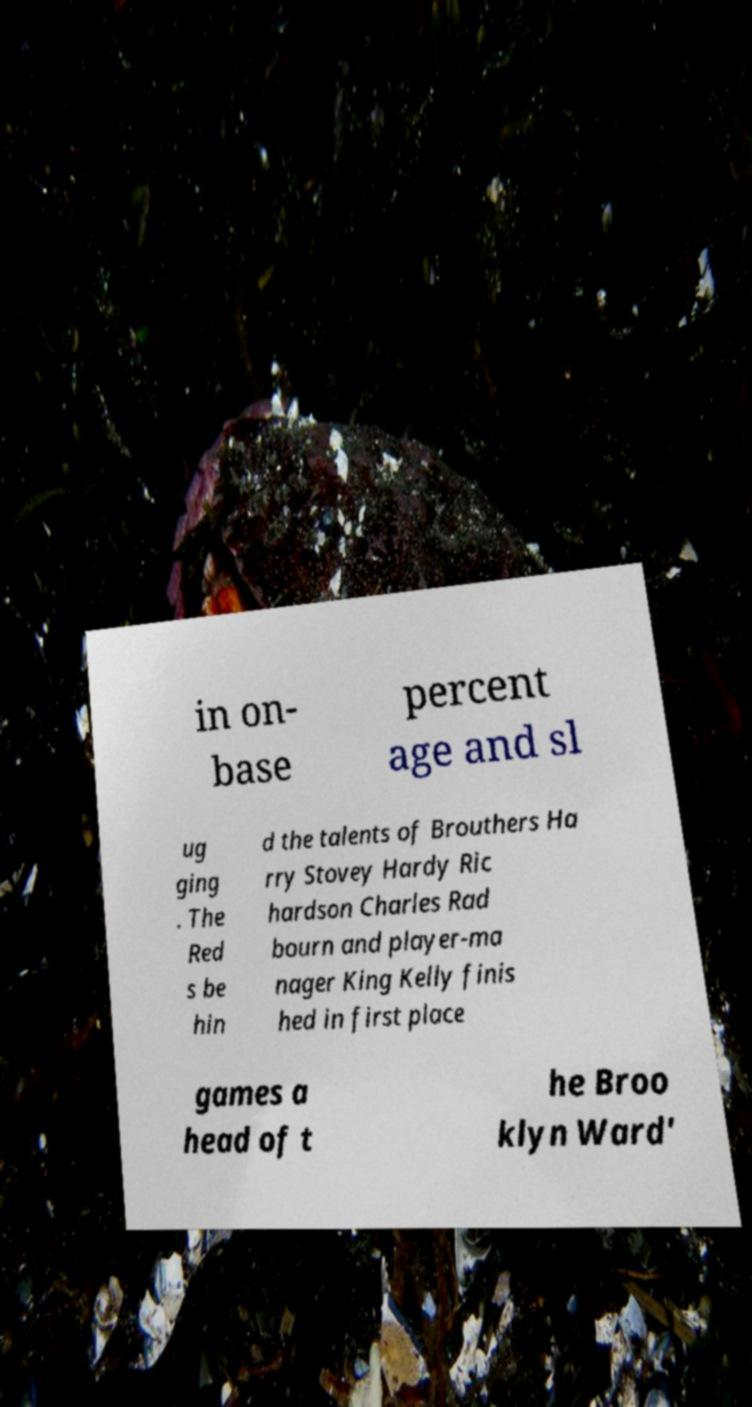I need the written content from this picture converted into text. Can you do that? in on- base percent age and sl ug ging . The Red s be hin d the talents of Brouthers Ha rry Stovey Hardy Ric hardson Charles Rad bourn and player-ma nager King Kelly finis hed in first place games a head of t he Broo klyn Ward' 